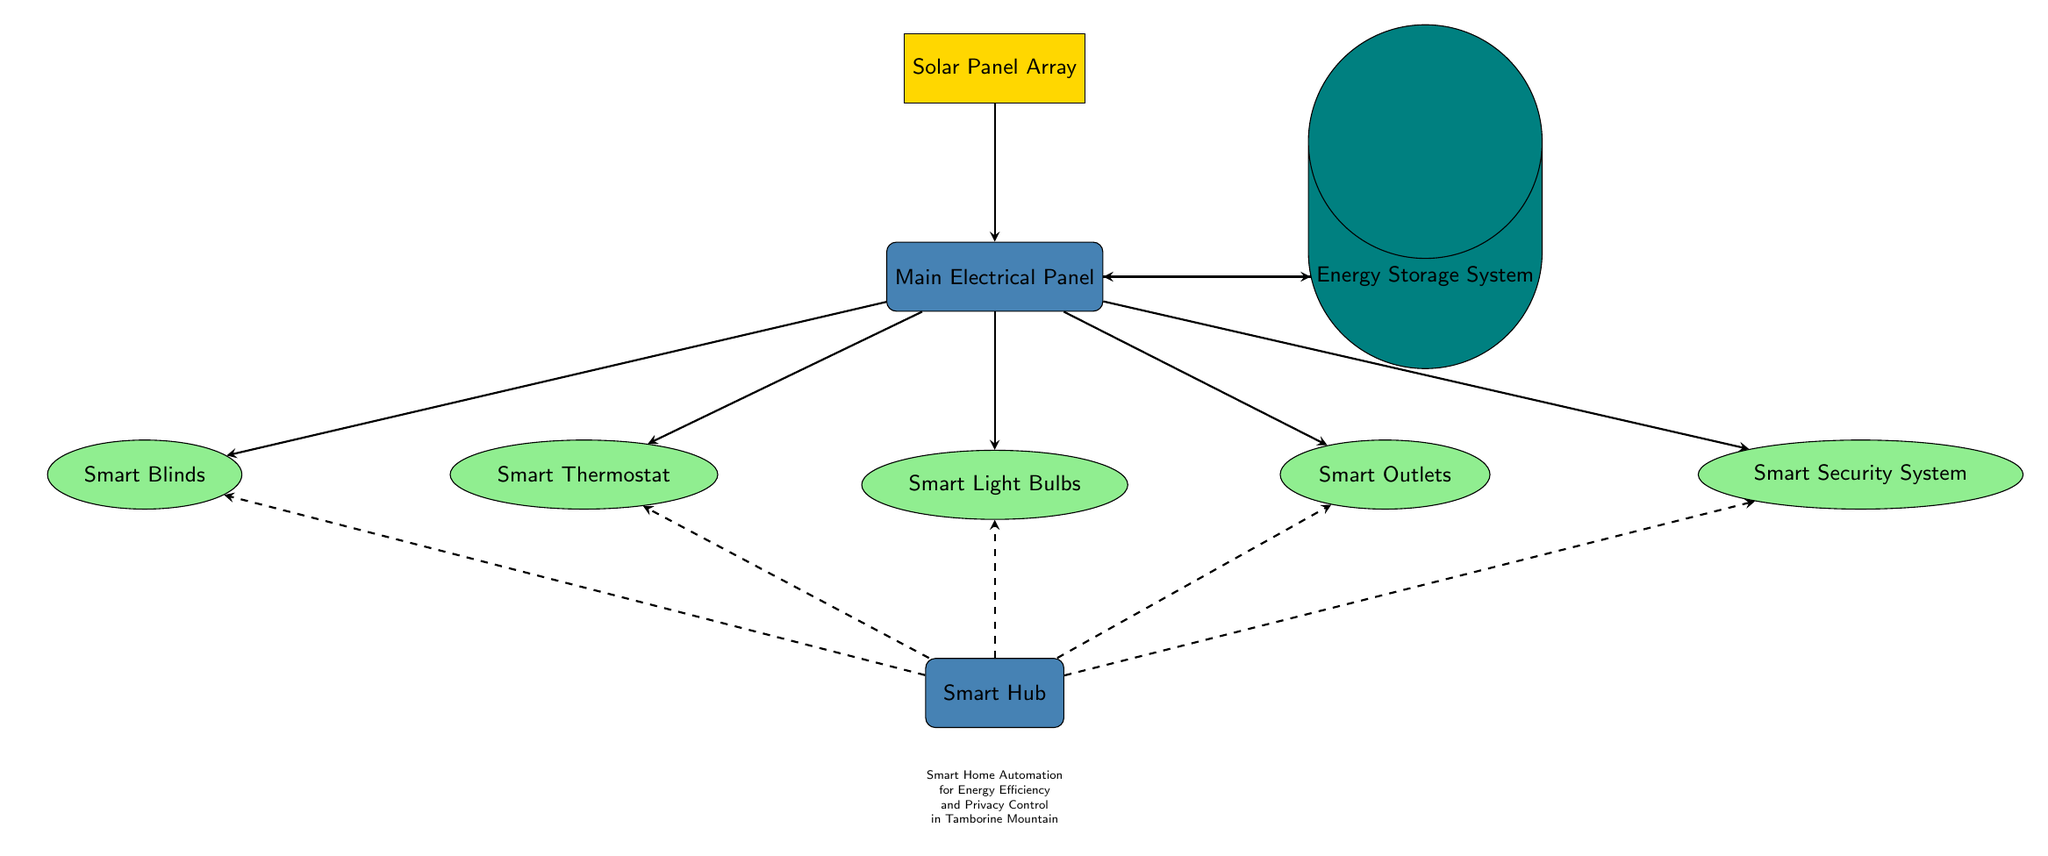What is the main power source for the system? The main power source for the system is indicated by the node labelled "Solar Panel Array," which is at the top of the diagram.
Answer: Solar Panel Array How many devices are connected to the main electrical panel? Counting the nodes connected directly to the "Main Electrical Panel," there are five devices: Smart Thermostat, Smart Light Bulbs, Smart Outlets, Smart Blinds, and Smart Security System.
Answer: Five What connects the battery to the main electrical panel? The connection from the battery to the main electrical panel is represented by an arrow, indicating a flow of energy/storage.
Answer: Arrow Which two devices are located directly beneath the lights? The "Smart Hub" is directly beneath the "Smart Light Bulbs," while the "Smart Thermostat" is above "Smart Light Bulbs." The question specifies devices below, indicating they are connected vertically.
Answer: Smart Hub What facilitates communication between the control hub and devices? The dashed arrows indicate the flow of communication from the "Smart Hub" to each of the devices: Smart Thermostat, Smart Light Bulbs, Smart Outlets, Smart Blinds, and Smart Security System.
Answer: Dashed arrows What type of energy storage system is depicted? The diagram includes a node labelled "Energy Storage System," which is represented by a cylinder indicating it is some form of battery storage.
Answer: Energy Storage System How does the energy flow from the solar panel? The arrow shows that energy flows from the "Solar Panel Array" to the "Main Electrical Panel," indicating it powers the system as its first step.
Answer: Main Electrical Panel What is the purpose of the control unit in the diagram? The purpose of the "Smart Hub" is to manage and control the interaction between the connected devices for energy efficiency and privacy control, as noted in the subtitle of the diagram.
Answer: Smart Hub What are the two colors used for the battery and control unit? The "Energy Storage System" is filled with a teal color, while the "Smart Hub" is filled with a blue color, representing different functions in the electrical circuit.
Answer: Teal and blue 